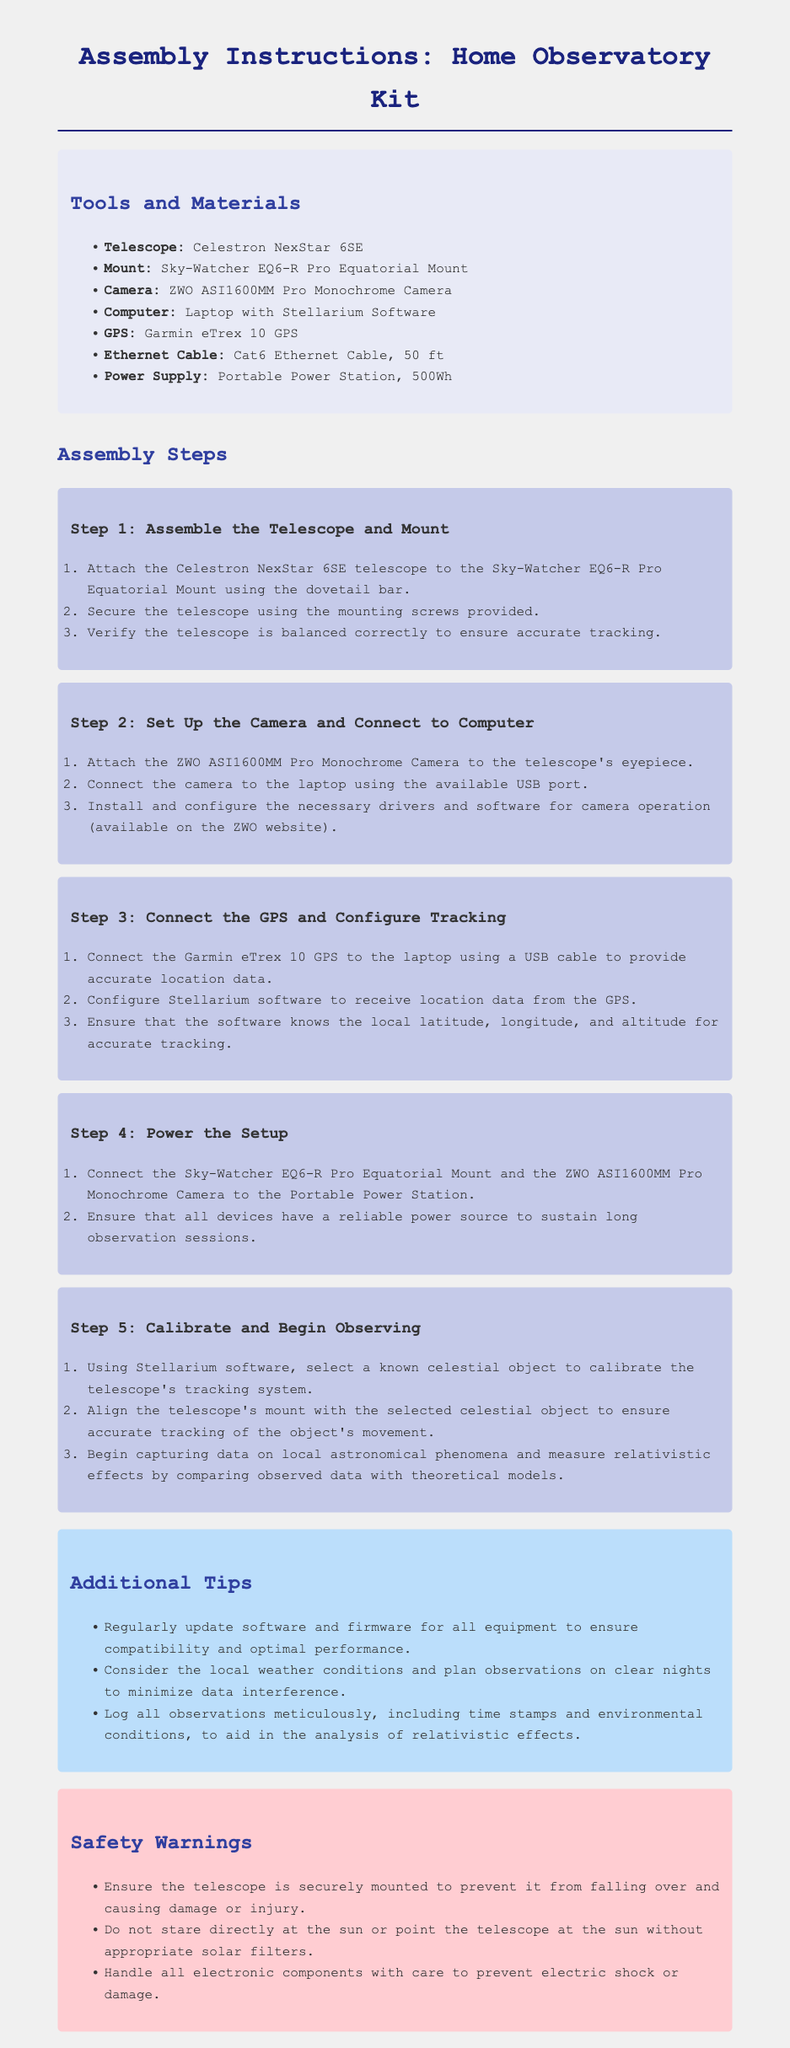What is the name of the telescope used? The telescope specified in the document is the Celestron NexStar 6SE.
Answer: Celestron NexStar 6SE How many steps are there in the assembly instructions? The assembly instructions have five distinct steps outlined in the document.
Answer: 5 What camera is included in the kit? The document lists the ZWO ASI1600MM Pro Monochrome Camera as part of the kit.
Answer: ZWO ASI1600MM Pro Monochrome Camera What is the recommended power supply? The assembly instructions recommend using a Portable Power Station, 500Wh for the setup.
Answer: Portable Power Station, 500Wh Which software is suggested for use with the computer? The document mentions Stellarium Software for use with the laptop in the assembly.
Answer: Stellarium Software What is the purpose of the Garmin eTrex 10? The Garmin eTrex 10 serves to provide accurate location data for configuring tracking in the Stellarium software.
Answer: Accurate location data What should you consider when logging observations? The instructions advise logging the time stamps and environmental conditions meticulously.
Answer: Time stamps and environmental conditions Why is it important to regularly update the software? Updating software and firmware ensures compatibility and optimal performance of all equipment.
Answer: Compatibility and optimal performance What should be avoided when using the telescope during the day? The document warns against staring directly at the sun or pointing the telescope at it without solar filters.
Answer: Staring directly at the sun 